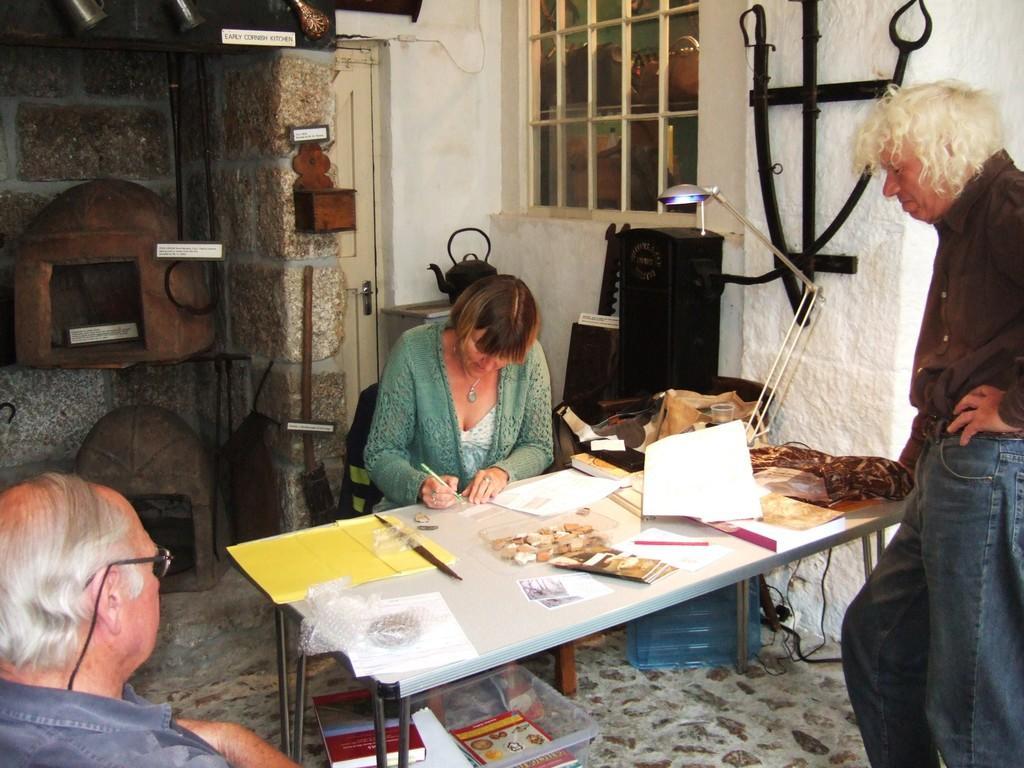Could you give a brief overview of what you see in this image? It is a home. in the middle the home we can find a woman sitting on a chair and table before the table one person, man is sitting. She writing something on a paper. In the background we can find wall, window and somethings. 